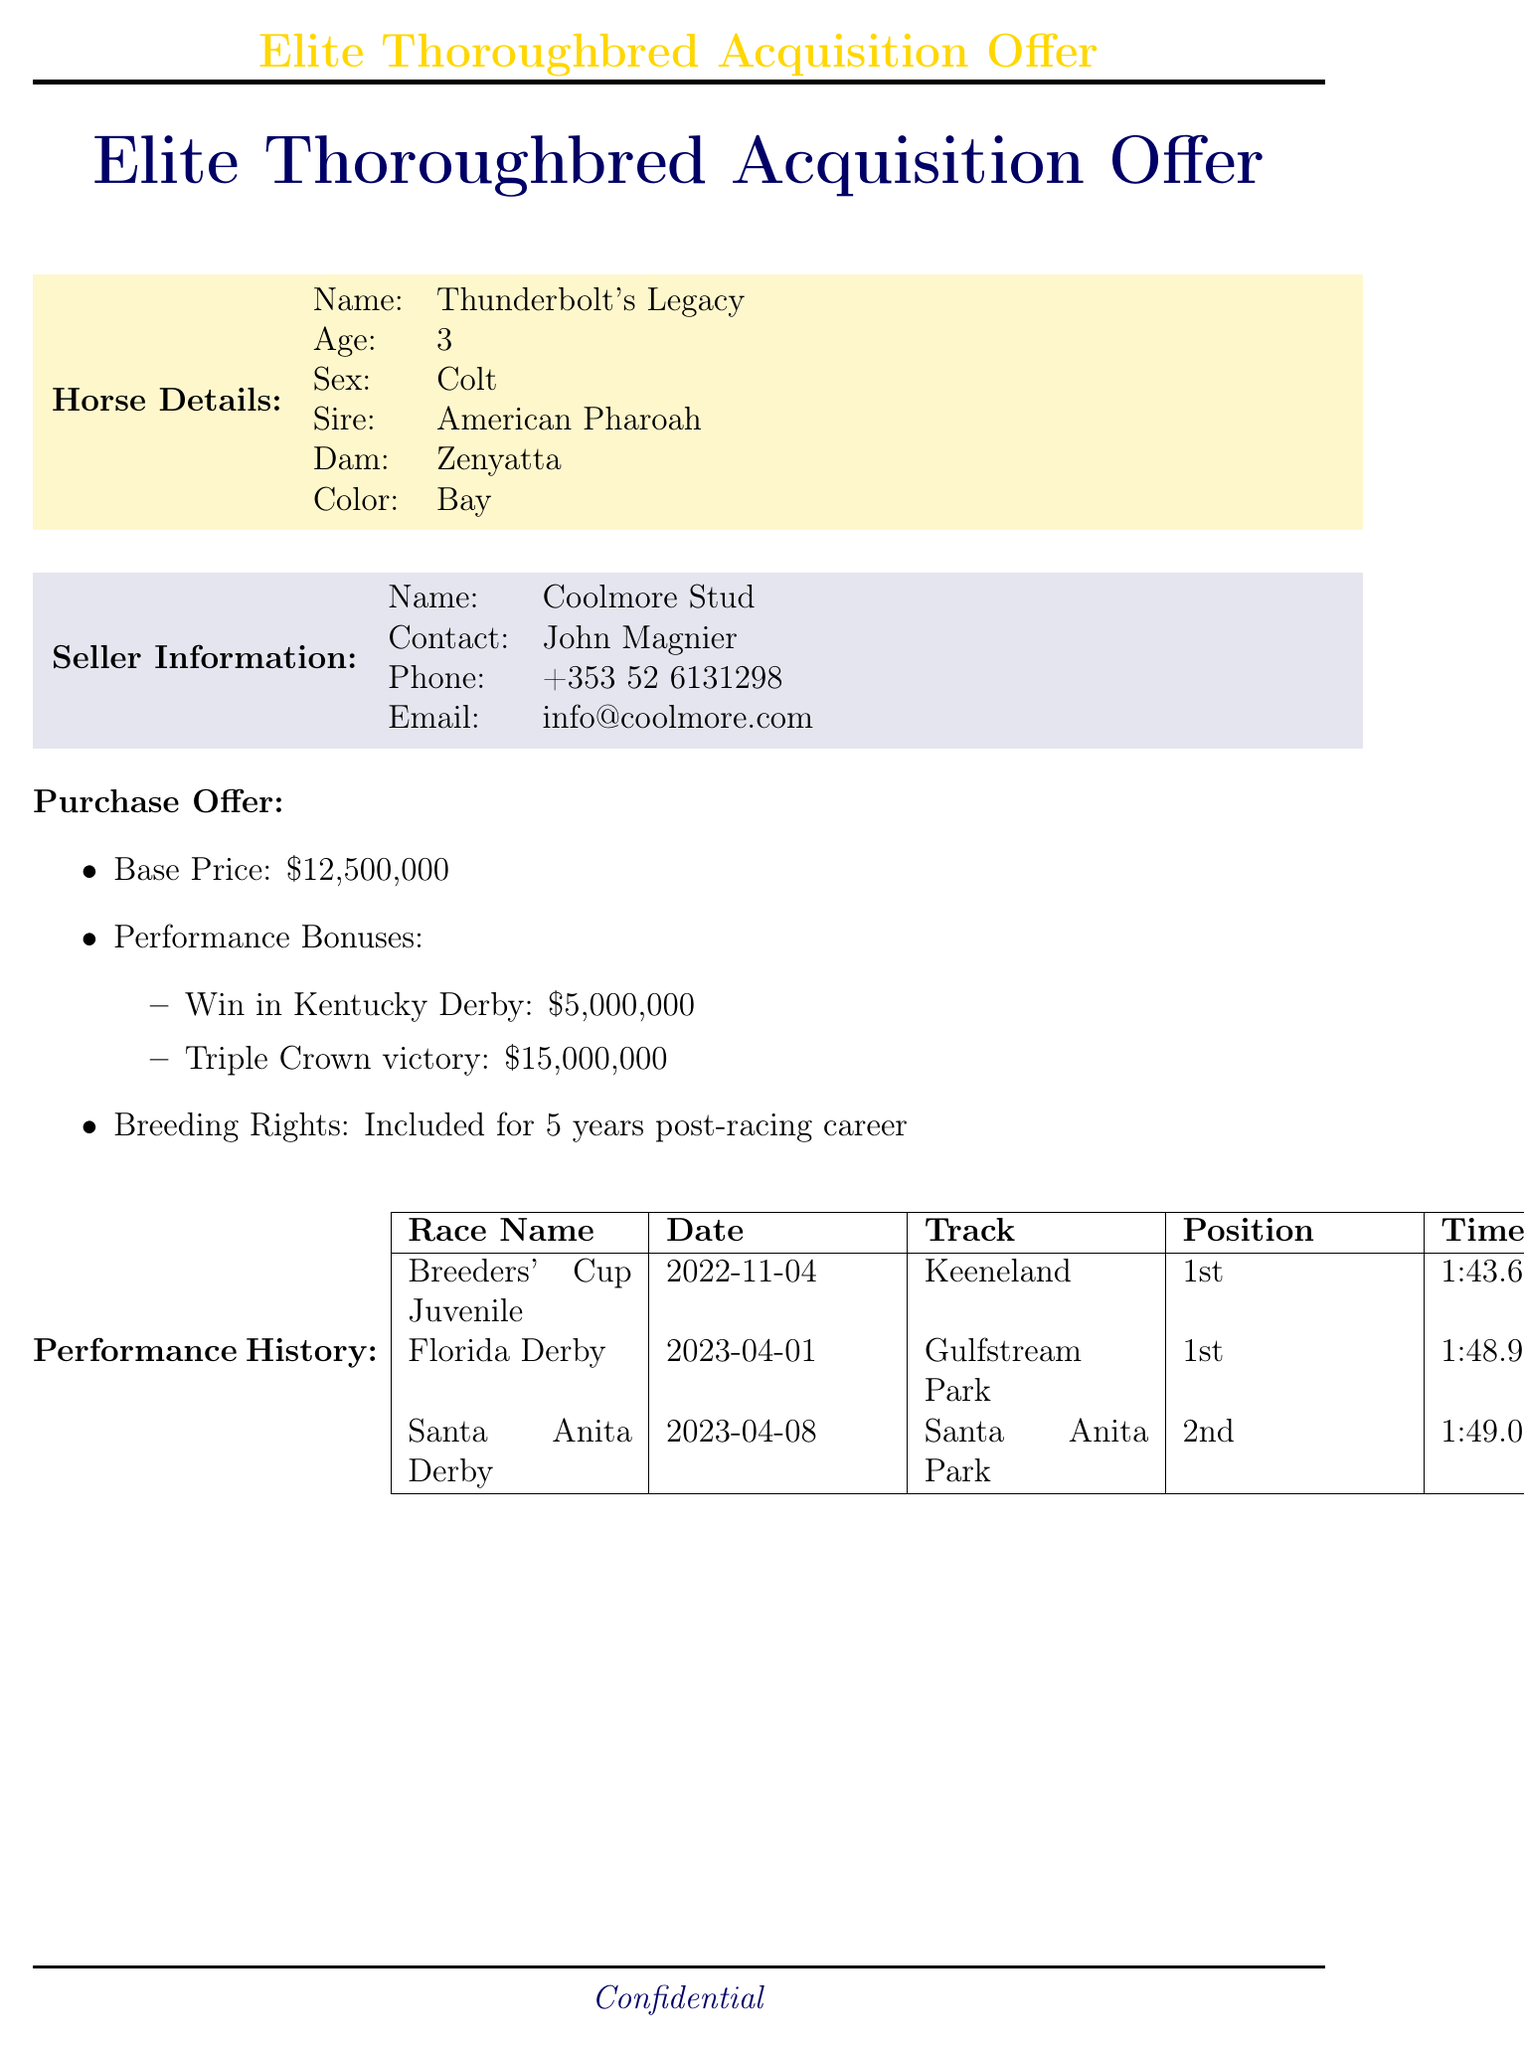What is the name of the horse? The document specifies that the horse's name is Thunderbolt's Legacy.
Answer: Thunderbolt's Legacy What is the base price offered for the horse? The base price for the horse is clearly listed as twelve million five hundred thousand dollars.
Answer: $12,500,000 Who is the examining veterinarian? The document indicates that Dr. Larry Bramlage conducted the veterinary examination.
Answer: Dr. Larry Bramlage What was Thunderbolt's Legacy's finish position in the Florida Derby? The document states that Thunderbolt's Legacy finished in first place in the Florida Derby.
Answer: 1st How long are the breeding rights included with the horse? The document mentions that breeding rights are included for five years post-racing career.
Answer: 5 years What is the date of the veterinary examination? The document specifies that the veterinary examination took place on May first, twenty twenty-three.
Answer: 2023-05-01 What is the total amount of performance bonuses if the horse wins the Triple Crown? The document lists the bonus for a Triple Crown victory as fifteen million dollars.
Answer: $15,000,000 Is the sale contingent on drug tests? The document states that the sale is indeed contingent upon the horse passing all required drug tests.
Answer: Yes What is listed as the overall health status of the horse? The document indicates that the overall health status of the horse is excellent.
Answer: Excellent 